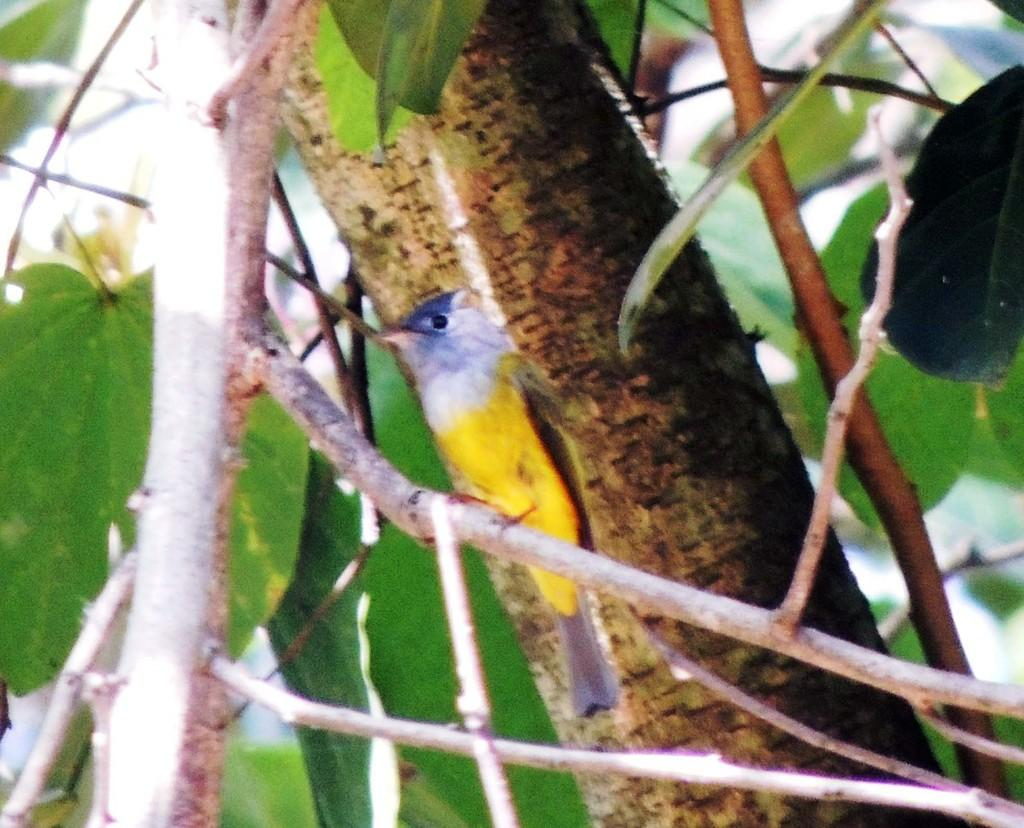What type of vegetation can be seen in the image? There are branches and leaves in the image. What type of animal is present in the image? There is a bird in the image. How many rings are visible on the bird's beak in the image? There are no rings visible on the bird's beak in the image. What shape is the bird's nest in the image? There is no nest present in the image, only a bird. 